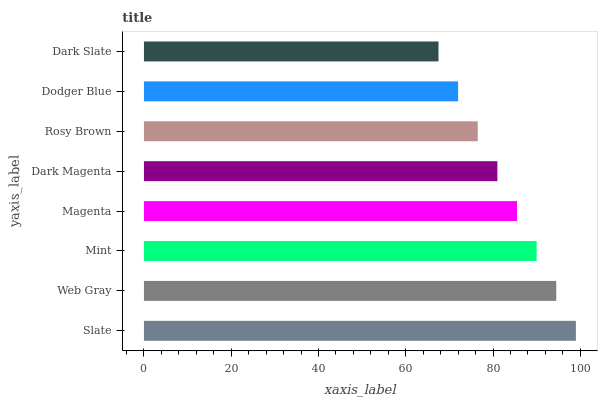Is Dark Slate the minimum?
Answer yes or no. Yes. Is Slate the maximum?
Answer yes or no. Yes. Is Web Gray the minimum?
Answer yes or no. No. Is Web Gray the maximum?
Answer yes or no. No. Is Slate greater than Web Gray?
Answer yes or no. Yes. Is Web Gray less than Slate?
Answer yes or no. Yes. Is Web Gray greater than Slate?
Answer yes or no. No. Is Slate less than Web Gray?
Answer yes or no. No. Is Magenta the high median?
Answer yes or no. Yes. Is Dark Magenta the low median?
Answer yes or no. Yes. Is Dark Slate the high median?
Answer yes or no. No. Is Magenta the low median?
Answer yes or no. No. 